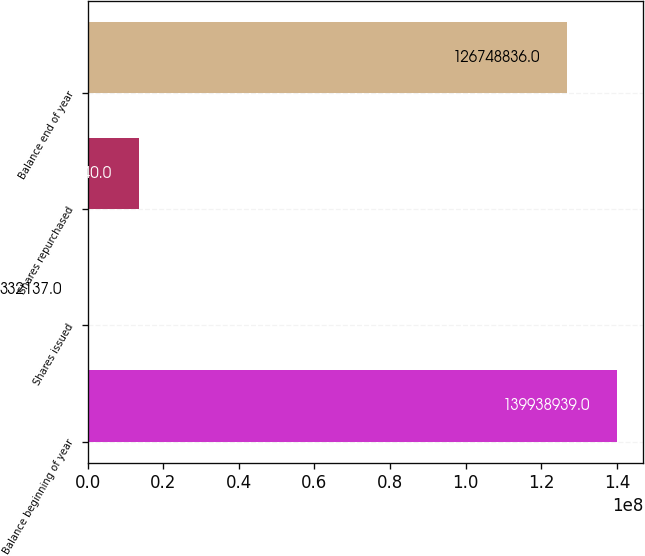<chart> <loc_0><loc_0><loc_500><loc_500><bar_chart><fcel>Balance beginning of year<fcel>Shares issued<fcel>Shares repurchased<fcel>Balance end of year<nl><fcel>1.39939e+08<fcel>332137<fcel>1.35222e+07<fcel>1.26749e+08<nl></chart> 